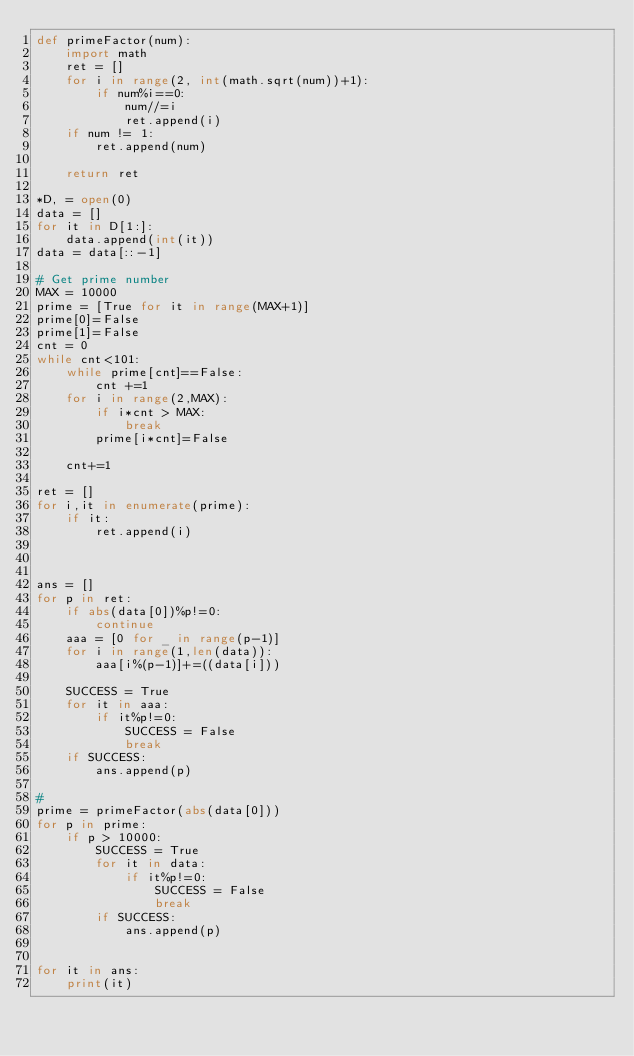<code> <loc_0><loc_0><loc_500><loc_500><_Python_>def primeFactor(num):
    import math
    ret = []
    for i in range(2, int(math.sqrt(num))+1):
        if num%i==0:
            num//=i
            ret.append(i)
    if num != 1:
        ret.append(num)
        
    return ret
  
*D, = open(0)
data = []
for it in D[1:]:
    data.append(int(it))
data = data[::-1]

# Get prime number
MAX = 10000
prime = [True for it in range(MAX+1)]
prime[0]=False
prime[1]=False
cnt = 0
while cnt<101:
    while prime[cnt]==False:
        cnt +=1
    for i in range(2,MAX):
        if i*cnt > MAX:
            break
        prime[i*cnt]=False
        
    cnt+=1

ret = []
for i,it in enumerate(prime):
    if it:
        ret.append(i)
        
        
        
ans = []
for p in ret:
    if abs(data[0])%p!=0:
        continue
    aaa = [0 for _ in range(p-1)]
    for i in range(1,len(data)):
        aaa[i%(p-1)]+=((data[i]))
        
    SUCCESS = True
    for it in aaa:
        if it%p!=0:
            SUCCESS = False
            break
    if SUCCESS:
        ans.append(p)
    
#
prime = primeFactor(abs(data[0]))
for p in prime:
    if p > 10000:
        SUCCESS = True
        for it in data:
            if it%p!=0:
                SUCCESS = False
                break
        if SUCCESS:
            ans.append(p)
            
            
for it in ans:
    print(it)</code> 